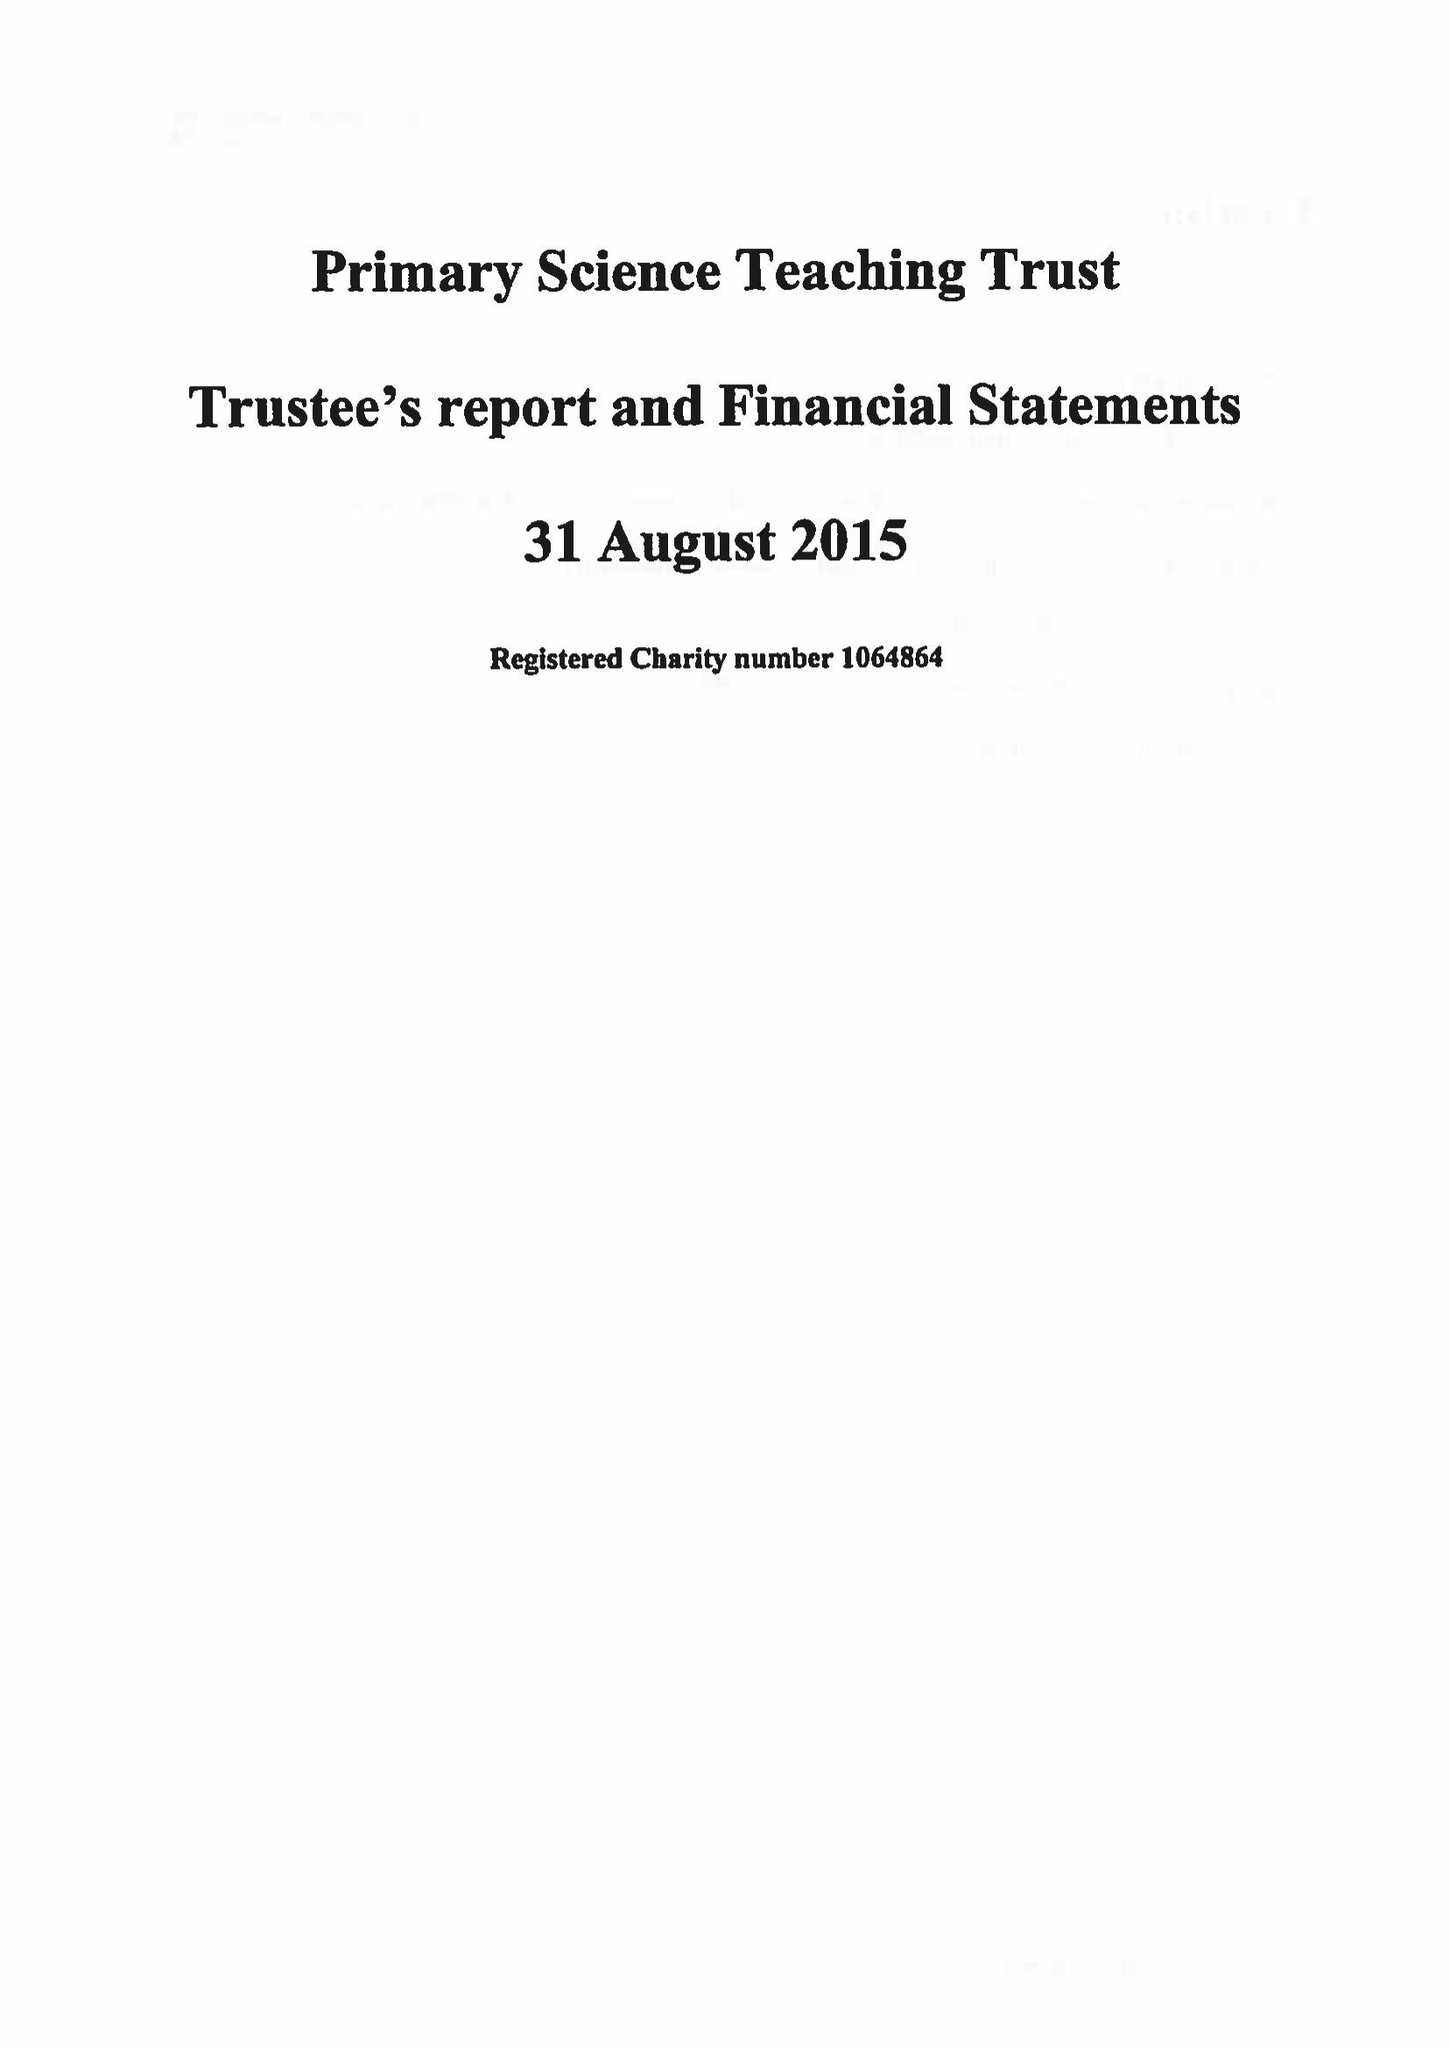What is the value for the report_date?
Answer the question using a single word or phrase. 2015-08-31 